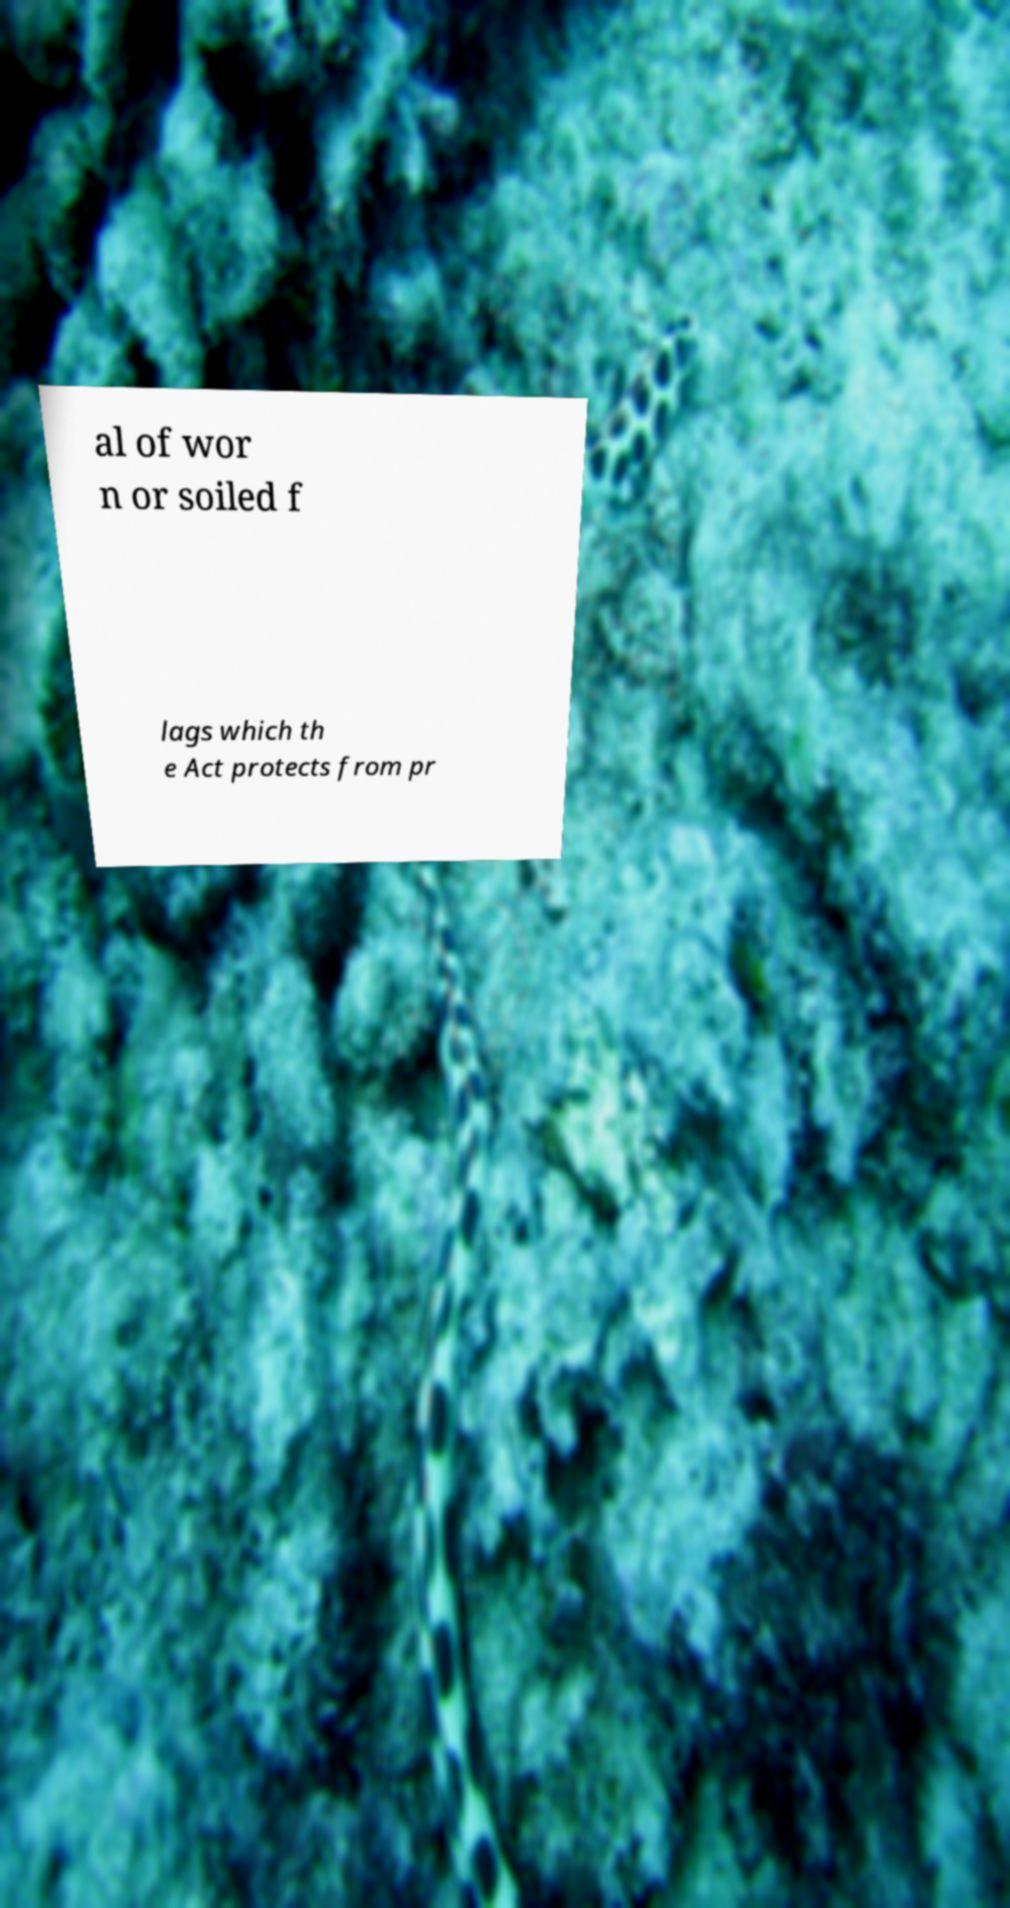For documentation purposes, I need the text within this image transcribed. Could you provide that? al of wor n or soiled f lags which th e Act protects from pr 